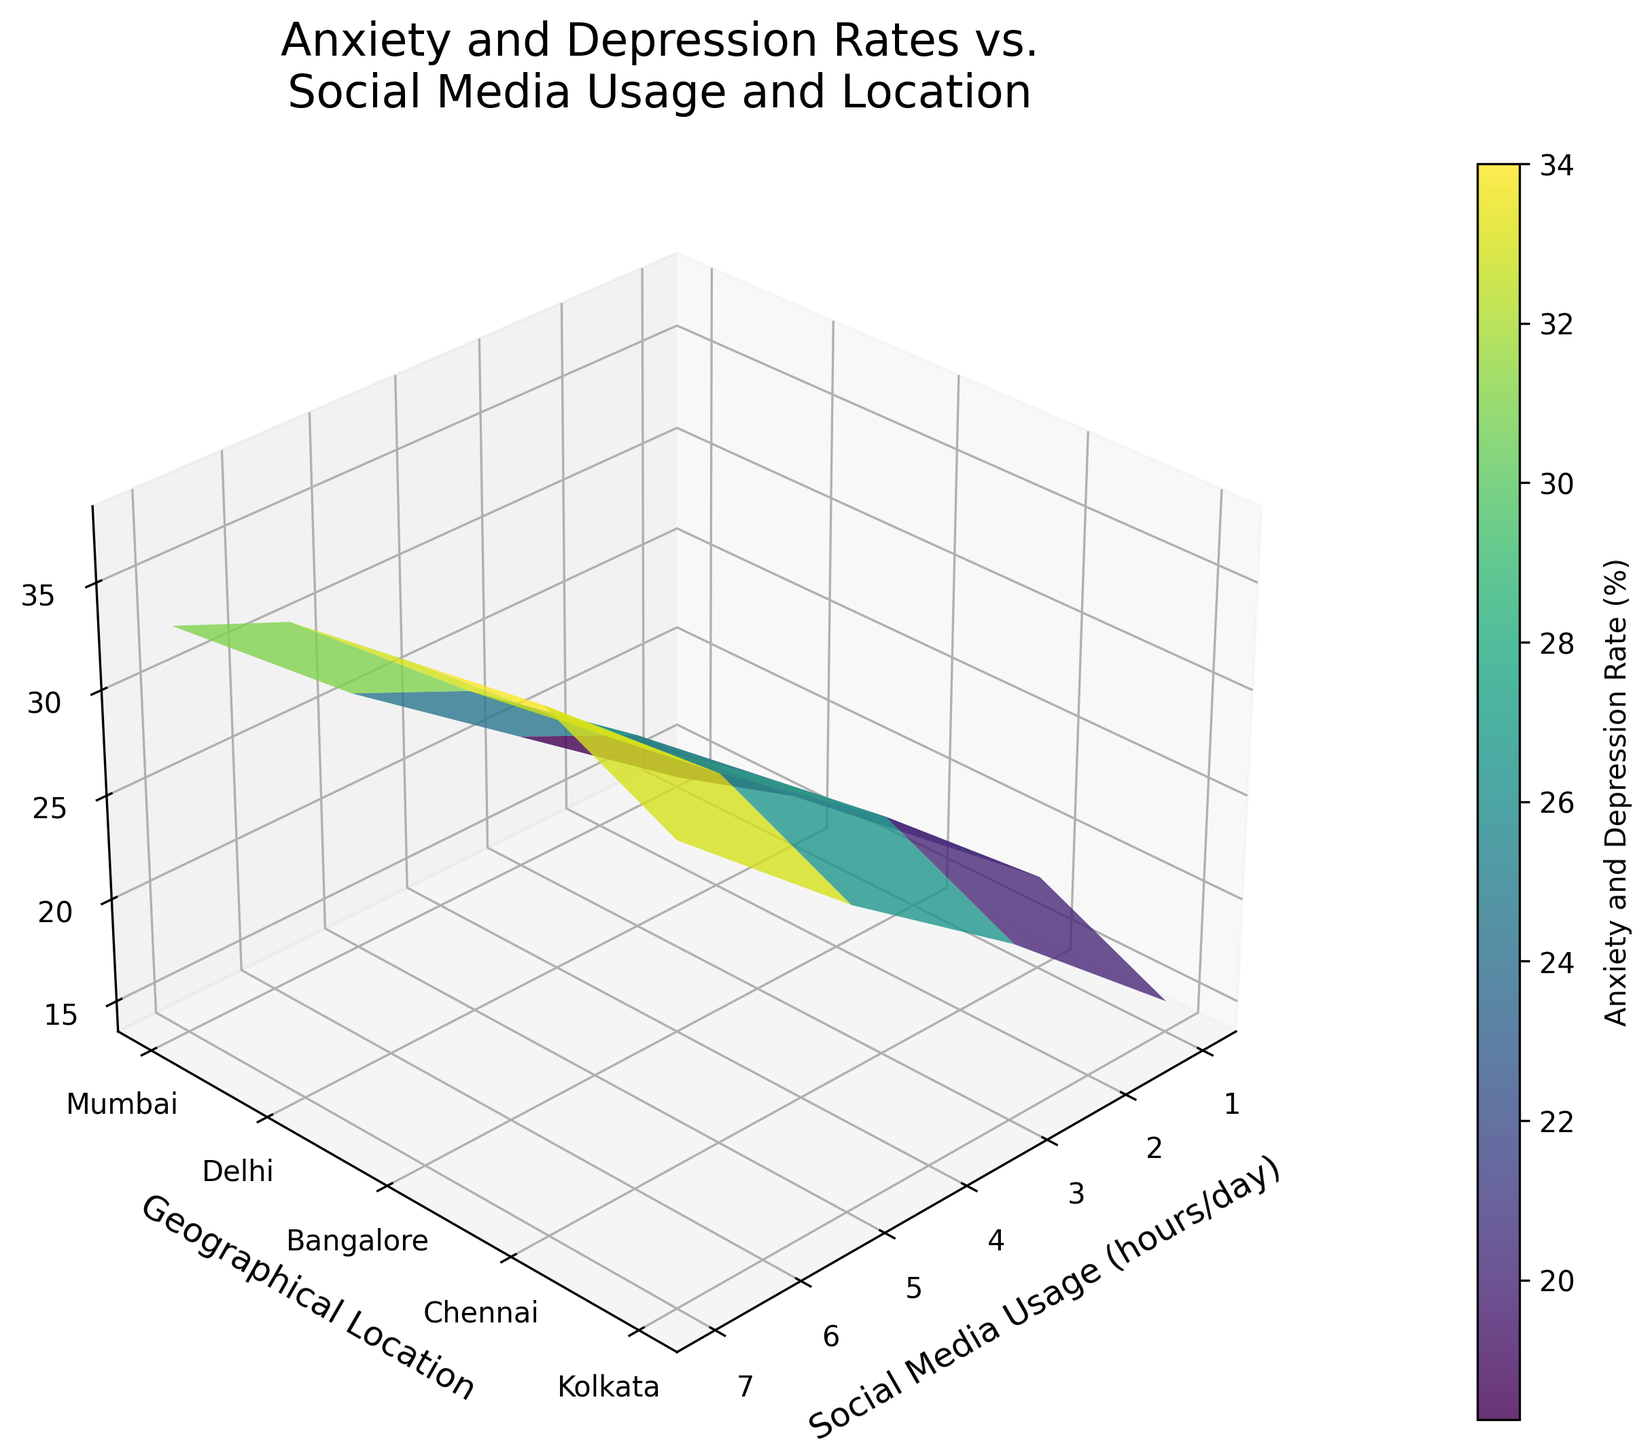What is the title of the plot? The title is displayed at the top of the plot and reads "Anxiety and Depression Rates vs. Social Media Usage and Location".
Answer: Anxiety and Depression Rates vs. Social Media Usage and Location How does the Anxiety and Depression Rate change with Social Media Usage in Mumbai? The surface plot shows an upward slope for Mumbai as Social Media Usage increases, indicating that Anxiety and Depression Rates increase with higher Social Media Usage.
Answer: It increases What is the Anxiety and Depression Rate for 5 hours/day Social Media usage in Delhi? Locate Delhi on the y-axis and 5 on the x-axis, then find the corresponding z-value on the surface plot.
Answer: 30% What is the difference in Anxiety and Depression Rates between 1 hour/day and 7 hours/day of Social Media Usage in Kolkata? For Kolkata, compare the z-values at 1 hour/day and 7 hours/day of Social Media Usage. The values are 18% and 38%, respectively. The difference is 38% - 18% = 20%.
Answer: 20% Compare the Anxiety and Depression Rates between Chennai and Bangalore for 3 hours/day of Social Media Usage. Locate 3 hours/day on the x-axis, find the Anxiety and Depression Rates for both Chennai and Bangalore by following their respective positions on the y-axis. Chennai has 23%, while Bangalore has 20%.
Answer: Chennai is higher What's the increase in Anxiety and Depression Rate in Chennai when Social Media Usage changes from 1 hour/day to 7 hours/day? Find the z-values for 1 hour/day (16%) and 7 hours/day (36%) in Chennai, then calculate the difference: 36% - 16% = 20%.
Answer: 20% Which city has the highest Anxiety and Depression Rate for 7 hours/day of Social Media Usage? Identify the cities on the y-axis and compare their z-values at 7 hours/day of Social Media Usage. Kolkata has the highest rate at 38%.
Answer: Kolkata Is there a significant difference in Anxiety and Depression Rates across different cities for 1 hour/day of Social Media Usage? Examine the z-values for each city at 1 hour/day on the surface plot. Rates fluctuate slightly from 14% to 18%, indicating minor differences.
Answer: No How does the color change on the surface plot reflect the Anxiety and Depression Rates? The color gradient on the surface plot ranges from cool (low rates) to warm (high rates) tones. As Anxiety and Depression Rates increase, the color shifts from green to yellow.
Answer: Green to yellow What is the average Anxiety and Depression Rate for 5 hours/day of Social Media Usage across all cities? Sum the z-values for all cities at 5 hours/day (28% for Mumbai, 30% for Delhi, 26% for Bangalore, 29% for Chennai, 31% for Kolkata) and divide by 5. (28 + 30 + 26 + 29 + 31) / 5 = 28.8%.
Answer: 28.8% 